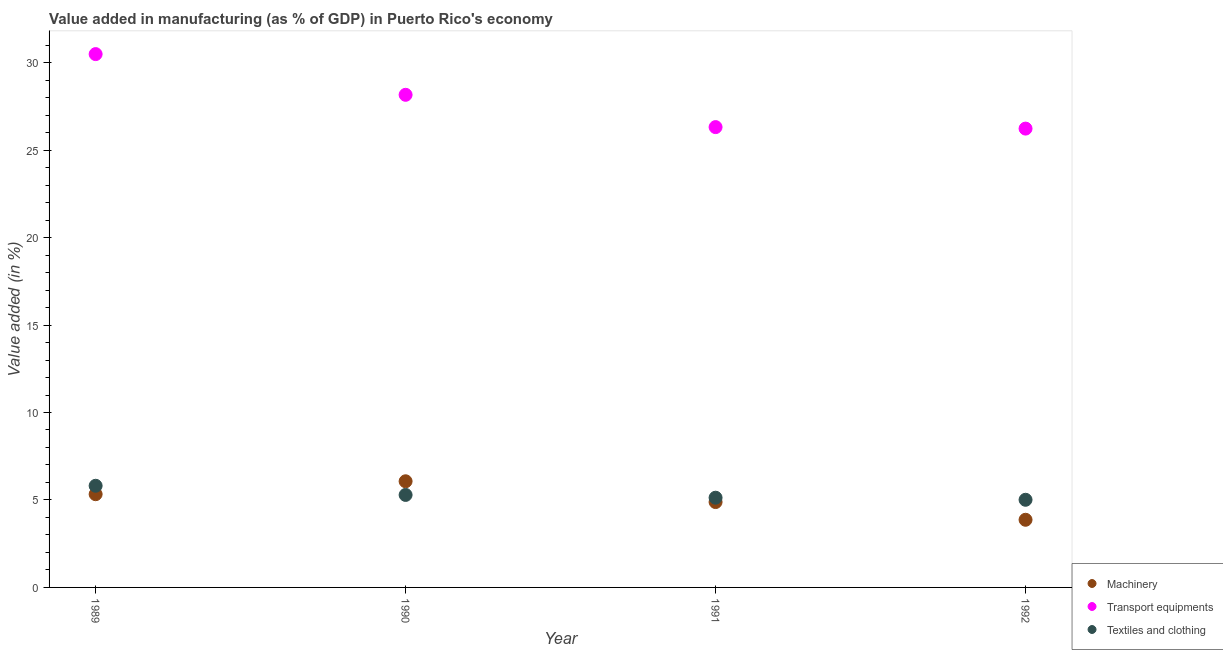What is the value added in manufacturing transport equipments in 1991?
Provide a short and direct response. 26.31. Across all years, what is the maximum value added in manufacturing textile and clothing?
Offer a terse response. 5.81. Across all years, what is the minimum value added in manufacturing machinery?
Your answer should be compact. 3.87. What is the total value added in manufacturing textile and clothing in the graph?
Make the answer very short. 21.24. What is the difference between the value added in manufacturing machinery in 1990 and that in 1991?
Offer a very short reply. 1.19. What is the difference between the value added in manufacturing textile and clothing in 1989 and the value added in manufacturing transport equipments in 1991?
Your response must be concise. -20.5. What is the average value added in manufacturing machinery per year?
Your response must be concise. 5.04. In the year 1989, what is the difference between the value added in manufacturing textile and clothing and value added in manufacturing machinery?
Provide a succinct answer. 0.48. What is the ratio of the value added in manufacturing transport equipments in 1989 to that in 1990?
Provide a succinct answer. 1.08. Is the difference between the value added in manufacturing transport equipments in 1989 and 1992 greater than the difference between the value added in manufacturing textile and clothing in 1989 and 1992?
Your response must be concise. Yes. What is the difference between the highest and the second highest value added in manufacturing textile and clothing?
Offer a terse response. 0.52. What is the difference between the highest and the lowest value added in manufacturing transport equipments?
Ensure brevity in your answer.  4.26. Is the sum of the value added in manufacturing transport equipments in 1990 and 1992 greater than the maximum value added in manufacturing machinery across all years?
Offer a very short reply. Yes. Does the value added in manufacturing transport equipments monotonically increase over the years?
Keep it short and to the point. No. Is the value added in manufacturing machinery strictly greater than the value added in manufacturing transport equipments over the years?
Your answer should be very brief. No. Is the value added in manufacturing textile and clothing strictly less than the value added in manufacturing machinery over the years?
Your response must be concise. No. How many dotlines are there?
Your answer should be compact. 3. How many years are there in the graph?
Your response must be concise. 4. Are the values on the major ticks of Y-axis written in scientific E-notation?
Keep it short and to the point. No. Does the graph contain any zero values?
Your answer should be very brief. No. How many legend labels are there?
Your response must be concise. 3. What is the title of the graph?
Ensure brevity in your answer.  Value added in manufacturing (as % of GDP) in Puerto Rico's economy. What is the label or title of the X-axis?
Give a very brief answer. Year. What is the label or title of the Y-axis?
Give a very brief answer. Value added (in %). What is the Value added (in %) in Machinery in 1989?
Give a very brief answer. 5.33. What is the Value added (in %) of Transport equipments in 1989?
Give a very brief answer. 30.49. What is the Value added (in %) of Textiles and clothing in 1989?
Offer a very short reply. 5.81. What is the Value added (in %) of Machinery in 1990?
Ensure brevity in your answer.  6.07. What is the Value added (in %) in Transport equipments in 1990?
Provide a short and direct response. 28.16. What is the Value added (in %) in Textiles and clothing in 1990?
Offer a very short reply. 5.29. What is the Value added (in %) in Machinery in 1991?
Offer a terse response. 4.88. What is the Value added (in %) in Transport equipments in 1991?
Your answer should be compact. 26.31. What is the Value added (in %) in Textiles and clothing in 1991?
Your answer should be compact. 5.13. What is the Value added (in %) of Machinery in 1992?
Your response must be concise. 3.87. What is the Value added (in %) of Transport equipments in 1992?
Provide a succinct answer. 26.23. What is the Value added (in %) of Textiles and clothing in 1992?
Ensure brevity in your answer.  5.01. Across all years, what is the maximum Value added (in %) of Machinery?
Make the answer very short. 6.07. Across all years, what is the maximum Value added (in %) in Transport equipments?
Your answer should be very brief. 30.49. Across all years, what is the maximum Value added (in %) in Textiles and clothing?
Offer a terse response. 5.81. Across all years, what is the minimum Value added (in %) in Machinery?
Keep it short and to the point. 3.87. Across all years, what is the minimum Value added (in %) of Transport equipments?
Give a very brief answer. 26.23. Across all years, what is the minimum Value added (in %) in Textiles and clothing?
Offer a terse response. 5.01. What is the total Value added (in %) in Machinery in the graph?
Give a very brief answer. 20.14. What is the total Value added (in %) of Transport equipments in the graph?
Give a very brief answer. 111.19. What is the total Value added (in %) in Textiles and clothing in the graph?
Keep it short and to the point. 21.24. What is the difference between the Value added (in %) of Machinery in 1989 and that in 1990?
Provide a succinct answer. -0.74. What is the difference between the Value added (in %) in Transport equipments in 1989 and that in 1990?
Provide a succinct answer. 2.33. What is the difference between the Value added (in %) in Textiles and clothing in 1989 and that in 1990?
Your answer should be compact. 0.52. What is the difference between the Value added (in %) of Machinery in 1989 and that in 1991?
Your response must be concise. 0.45. What is the difference between the Value added (in %) of Transport equipments in 1989 and that in 1991?
Make the answer very short. 4.17. What is the difference between the Value added (in %) of Textiles and clothing in 1989 and that in 1991?
Offer a terse response. 0.68. What is the difference between the Value added (in %) in Machinery in 1989 and that in 1992?
Give a very brief answer. 1.46. What is the difference between the Value added (in %) of Transport equipments in 1989 and that in 1992?
Your answer should be very brief. 4.26. What is the difference between the Value added (in %) in Textiles and clothing in 1989 and that in 1992?
Your response must be concise. 0.8. What is the difference between the Value added (in %) of Machinery in 1990 and that in 1991?
Offer a terse response. 1.19. What is the difference between the Value added (in %) of Transport equipments in 1990 and that in 1991?
Provide a short and direct response. 1.85. What is the difference between the Value added (in %) in Textiles and clothing in 1990 and that in 1991?
Provide a succinct answer. 0.16. What is the difference between the Value added (in %) in Machinery in 1990 and that in 1992?
Offer a very short reply. 2.2. What is the difference between the Value added (in %) of Transport equipments in 1990 and that in 1992?
Give a very brief answer. 1.93. What is the difference between the Value added (in %) in Textiles and clothing in 1990 and that in 1992?
Ensure brevity in your answer.  0.28. What is the difference between the Value added (in %) of Machinery in 1991 and that in 1992?
Provide a succinct answer. 1.01. What is the difference between the Value added (in %) of Transport equipments in 1991 and that in 1992?
Your answer should be compact. 0.09. What is the difference between the Value added (in %) in Textiles and clothing in 1991 and that in 1992?
Provide a short and direct response. 0.12. What is the difference between the Value added (in %) of Machinery in 1989 and the Value added (in %) of Transport equipments in 1990?
Provide a short and direct response. -22.83. What is the difference between the Value added (in %) of Machinery in 1989 and the Value added (in %) of Textiles and clothing in 1990?
Offer a very short reply. 0.04. What is the difference between the Value added (in %) of Transport equipments in 1989 and the Value added (in %) of Textiles and clothing in 1990?
Your answer should be very brief. 25.2. What is the difference between the Value added (in %) in Machinery in 1989 and the Value added (in %) in Transport equipments in 1991?
Ensure brevity in your answer.  -20.98. What is the difference between the Value added (in %) of Machinery in 1989 and the Value added (in %) of Textiles and clothing in 1991?
Offer a terse response. 0.2. What is the difference between the Value added (in %) of Transport equipments in 1989 and the Value added (in %) of Textiles and clothing in 1991?
Your response must be concise. 25.36. What is the difference between the Value added (in %) in Machinery in 1989 and the Value added (in %) in Transport equipments in 1992?
Your answer should be very brief. -20.9. What is the difference between the Value added (in %) of Machinery in 1989 and the Value added (in %) of Textiles and clothing in 1992?
Ensure brevity in your answer.  0.32. What is the difference between the Value added (in %) of Transport equipments in 1989 and the Value added (in %) of Textiles and clothing in 1992?
Your answer should be very brief. 25.48. What is the difference between the Value added (in %) of Machinery in 1990 and the Value added (in %) of Transport equipments in 1991?
Keep it short and to the point. -20.25. What is the difference between the Value added (in %) of Machinery in 1990 and the Value added (in %) of Textiles and clothing in 1991?
Keep it short and to the point. 0.94. What is the difference between the Value added (in %) of Transport equipments in 1990 and the Value added (in %) of Textiles and clothing in 1991?
Make the answer very short. 23.03. What is the difference between the Value added (in %) in Machinery in 1990 and the Value added (in %) in Transport equipments in 1992?
Offer a terse response. -20.16. What is the difference between the Value added (in %) of Machinery in 1990 and the Value added (in %) of Textiles and clothing in 1992?
Your response must be concise. 1.06. What is the difference between the Value added (in %) of Transport equipments in 1990 and the Value added (in %) of Textiles and clothing in 1992?
Your answer should be very brief. 23.15. What is the difference between the Value added (in %) of Machinery in 1991 and the Value added (in %) of Transport equipments in 1992?
Offer a terse response. -21.35. What is the difference between the Value added (in %) of Machinery in 1991 and the Value added (in %) of Textiles and clothing in 1992?
Give a very brief answer. -0.13. What is the difference between the Value added (in %) in Transport equipments in 1991 and the Value added (in %) in Textiles and clothing in 1992?
Keep it short and to the point. 21.3. What is the average Value added (in %) of Machinery per year?
Make the answer very short. 5.04. What is the average Value added (in %) of Transport equipments per year?
Your answer should be very brief. 27.8. What is the average Value added (in %) in Textiles and clothing per year?
Offer a terse response. 5.31. In the year 1989, what is the difference between the Value added (in %) in Machinery and Value added (in %) in Transport equipments?
Ensure brevity in your answer.  -25.16. In the year 1989, what is the difference between the Value added (in %) in Machinery and Value added (in %) in Textiles and clothing?
Offer a terse response. -0.48. In the year 1989, what is the difference between the Value added (in %) in Transport equipments and Value added (in %) in Textiles and clothing?
Your answer should be very brief. 24.68. In the year 1990, what is the difference between the Value added (in %) of Machinery and Value added (in %) of Transport equipments?
Provide a succinct answer. -22.09. In the year 1990, what is the difference between the Value added (in %) of Machinery and Value added (in %) of Textiles and clothing?
Keep it short and to the point. 0.78. In the year 1990, what is the difference between the Value added (in %) of Transport equipments and Value added (in %) of Textiles and clothing?
Give a very brief answer. 22.87. In the year 1991, what is the difference between the Value added (in %) in Machinery and Value added (in %) in Transport equipments?
Provide a short and direct response. -21.43. In the year 1991, what is the difference between the Value added (in %) in Machinery and Value added (in %) in Textiles and clothing?
Give a very brief answer. -0.25. In the year 1991, what is the difference between the Value added (in %) of Transport equipments and Value added (in %) of Textiles and clothing?
Provide a succinct answer. 21.19. In the year 1992, what is the difference between the Value added (in %) of Machinery and Value added (in %) of Transport equipments?
Your response must be concise. -22.36. In the year 1992, what is the difference between the Value added (in %) in Machinery and Value added (in %) in Textiles and clothing?
Give a very brief answer. -1.14. In the year 1992, what is the difference between the Value added (in %) in Transport equipments and Value added (in %) in Textiles and clothing?
Offer a very short reply. 21.22. What is the ratio of the Value added (in %) in Machinery in 1989 to that in 1990?
Ensure brevity in your answer.  0.88. What is the ratio of the Value added (in %) of Transport equipments in 1989 to that in 1990?
Make the answer very short. 1.08. What is the ratio of the Value added (in %) in Textiles and clothing in 1989 to that in 1990?
Your answer should be compact. 1.1. What is the ratio of the Value added (in %) in Machinery in 1989 to that in 1991?
Provide a short and direct response. 1.09. What is the ratio of the Value added (in %) of Transport equipments in 1989 to that in 1991?
Give a very brief answer. 1.16. What is the ratio of the Value added (in %) of Textiles and clothing in 1989 to that in 1991?
Provide a short and direct response. 1.13. What is the ratio of the Value added (in %) of Machinery in 1989 to that in 1992?
Your response must be concise. 1.38. What is the ratio of the Value added (in %) of Transport equipments in 1989 to that in 1992?
Provide a succinct answer. 1.16. What is the ratio of the Value added (in %) in Textiles and clothing in 1989 to that in 1992?
Ensure brevity in your answer.  1.16. What is the ratio of the Value added (in %) in Machinery in 1990 to that in 1991?
Provide a short and direct response. 1.24. What is the ratio of the Value added (in %) in Transport equipments in 1990 to that in 1991?
Ensure brevity in your answer.  1.07. What is the ratio of the Value added (in %) in Textiles and clothing in 1990 to that in 1991?
Provide a succinct answer. 1.03. What is the ratio of the Value added (in %) in Machinery in 1990 to that in 1992?
Give a very brief answer. 1.57. What is the ratio of the Value added (in %) in Transport equipments in 1990 to that in 1992?
Provide a succinct answer. 1.07. What is the ratio of the Value added (in %) in Textiles and clothing in 1990 to that in 1992?
Provide a short and direct response. 1.06. What is the ratio of the Value added (in %) in Machinery in 1991 to that in 1992?
Provide a short and direct response. 1.26. What is the ratio of the Value added (in %) of Textiles and clothing in 1991 to that in 1992?
Ensure brevity in your answer.  1.02. What is the difference between the highest and the second highest Value added (in %) in Machinery?
Make the answer very short. 0.74. What is the difference between the highest and the second highest Value added (in %) of Transport equipments?
Provide a short and direct response. 2.33. What is the difference between the highest and the second highest Value added (in %) in Textiles and clothing?
Provide a succinct answer. 0.52. What is the difference between the highest and the lowest Value added (in %) of Machinery?
Your answer should be compact. 2.2. What is the difference between the highest and the lowest Value added (in %) in Transport equipments?
Your answer should be compact. 4.26. What is the difference between the highest and the lowest Value added (in %) of Textiles and clothing?
Offer a terse response. 0.8. 